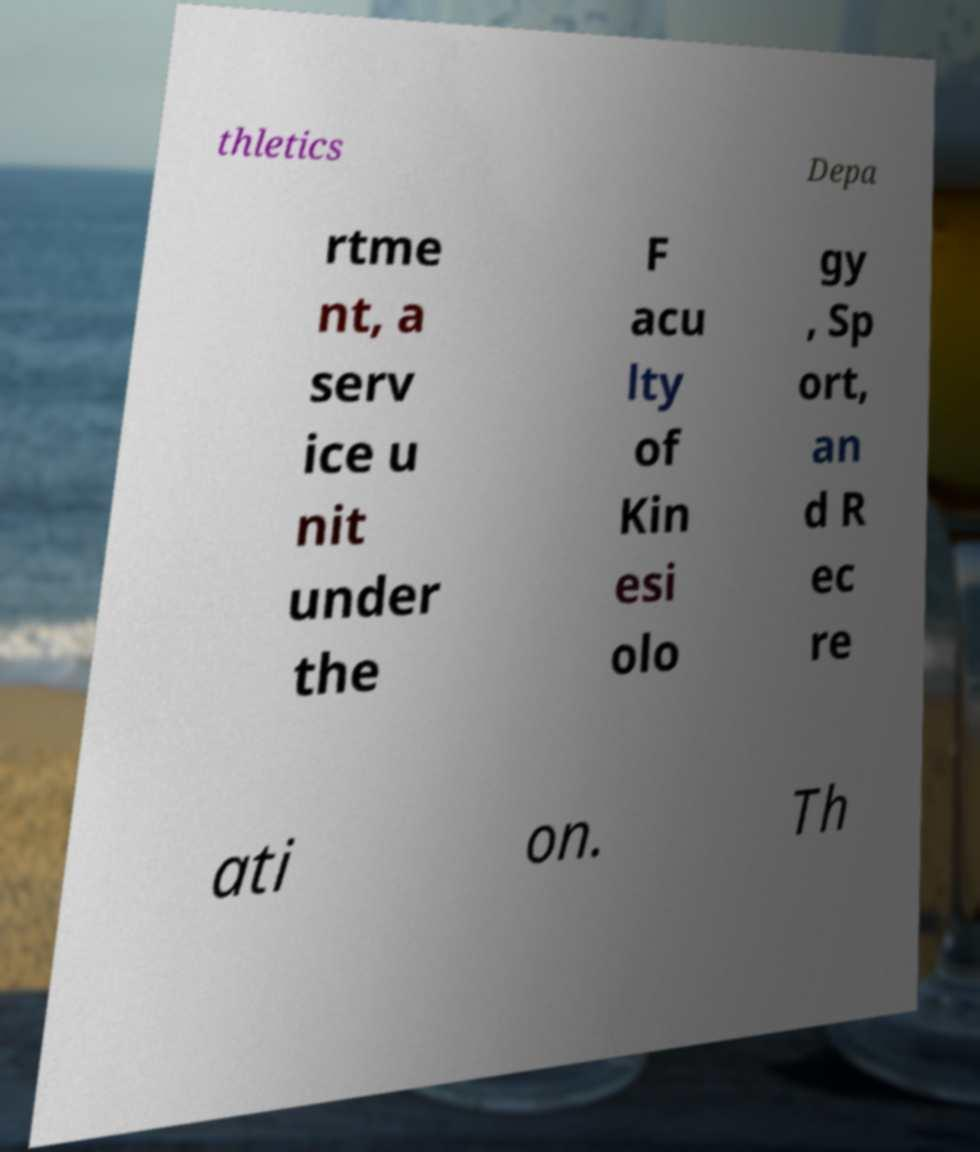I need the written content from this picture converted into text. Can you do that? thletics Depa rtme nt, a serv ice u nit under the F acu lty of Kin esi olo gy , Sp ort, an d R ec re ati on. Th 